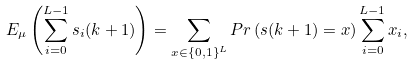Convert formula to latex. <formula><loc_0><loc_0><loc_500><loc_500>E _ { \mu } \left ( \sum _ { i = 0 } ^ { L - 1 } s _ { i } ( k + 1 ) \right ) = \sum _ { x \in \{ 0 , 1 \} ^ { L } } P r \left ( s ( k + 1 ) = x \right ) \sum _ { i = 0 } ^ { L - 1 } x _ { i } ,</formula> 